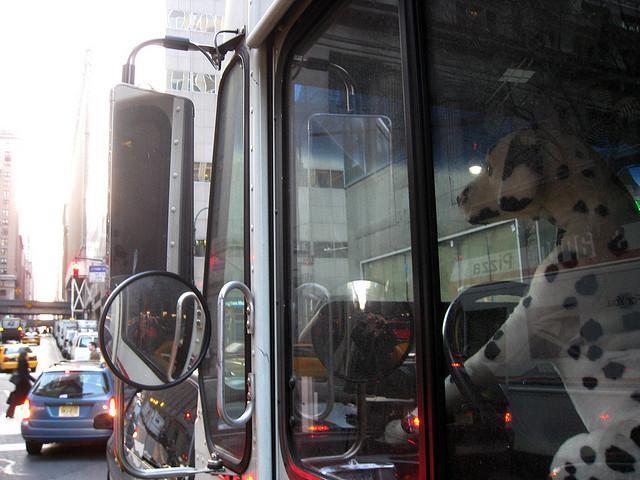Which lens is used in bus side mirror?
Indicate the correct response by choosing from the four available options to answer the question.
Options: Convex, pin point, cortex, concave. Convex. 